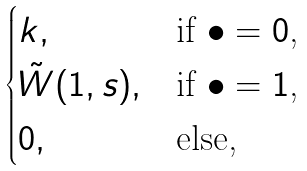Convert formula to latex. <formula><loc_0><loc_0><loc_500><loc_500>\begin{cases} k , & \text {if $\bullet = 0$,} \\ \tilde { W } ( 1 , s ) , & \text {if $\bullet = 1$,} \\ 0 , & \text {else,} \end{cases}</formula> 